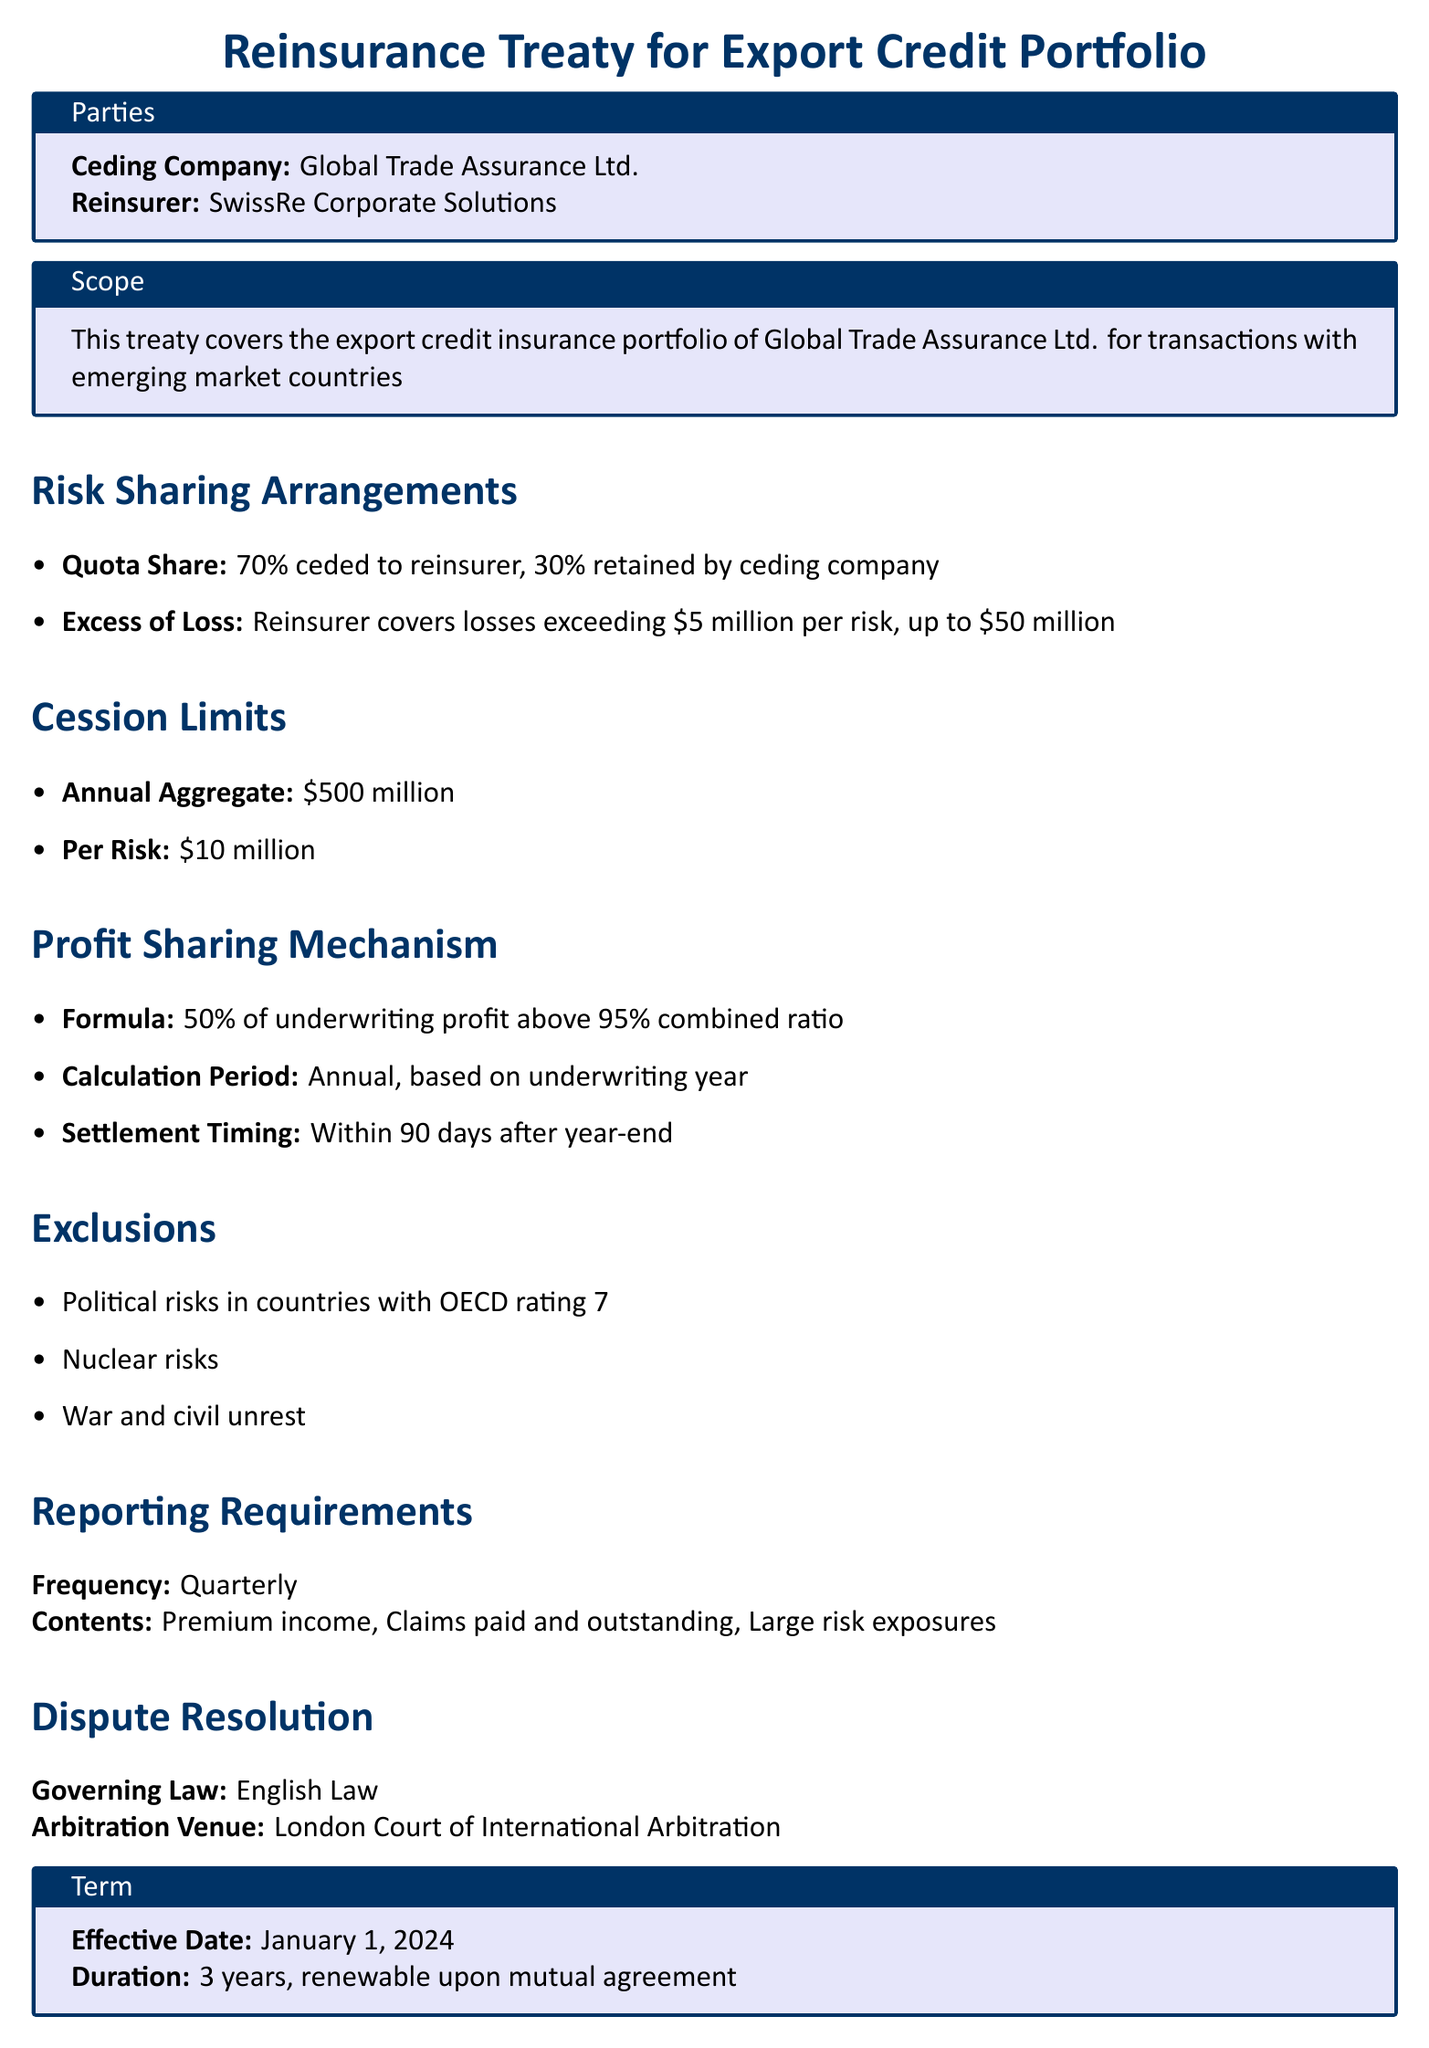What is the ceding percentage for the reinsurer? The document states that 70% is ceded to the reinsurer as part of the quota share arrangement.
Answer: 70% What is the annual aggregate cession limit? The document specifies that the annual aggregate cession limit is $500 million.
Answer: $500 million What is the maximum coverage per risk? The document mentions that the maximum coverage per risk is $10 million.
Answer: $10 million What percentage of underwriting profit is shared with the reinsurer? The document indicates that 50% of underwriting profit above a 95% combined ratio is shared.
Answer: 50% What is the effective date of the treaty? The document states that the effective date of the treaty is January 1, 2024.
Answer: January 1, 2024 Which law governs the dispute resolution? The document indicates that English Law governs the dispute resolution process.
Answer: English Law What types of risks are excluded from the policy? The document lists political risks in countries with OECD rating 7, nuclear risks, and war and civil unrest as exclusions.
Answer: Political risks, nuclear risks, war and civil unrest What is the timing for settlement of profit-sharing? The document specifies that settlement for profit-sharing occurs within 90 days after year-end.
Answer: 90 days What is the duration of the treaty? The document mentions that the duration of the treaty is 3 years, renewable upon mutual agreement.
Answer: 3 years 